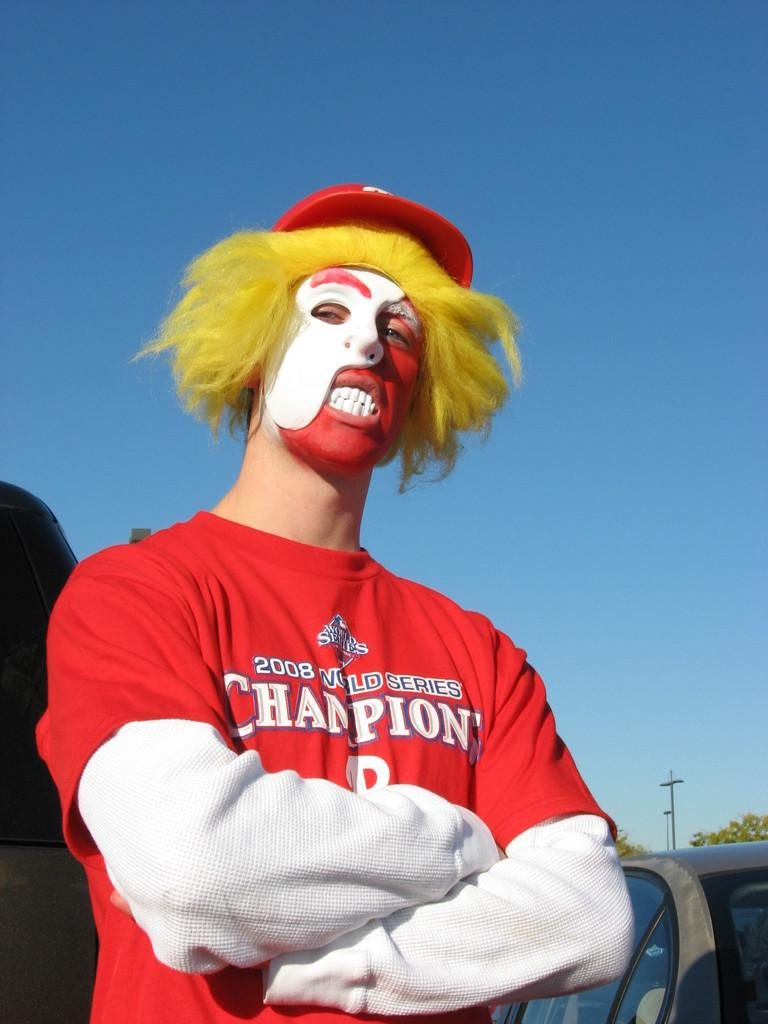<image>
Summarize the visual content of the image. A man wearing clown makeup wears a red Champion shirt 